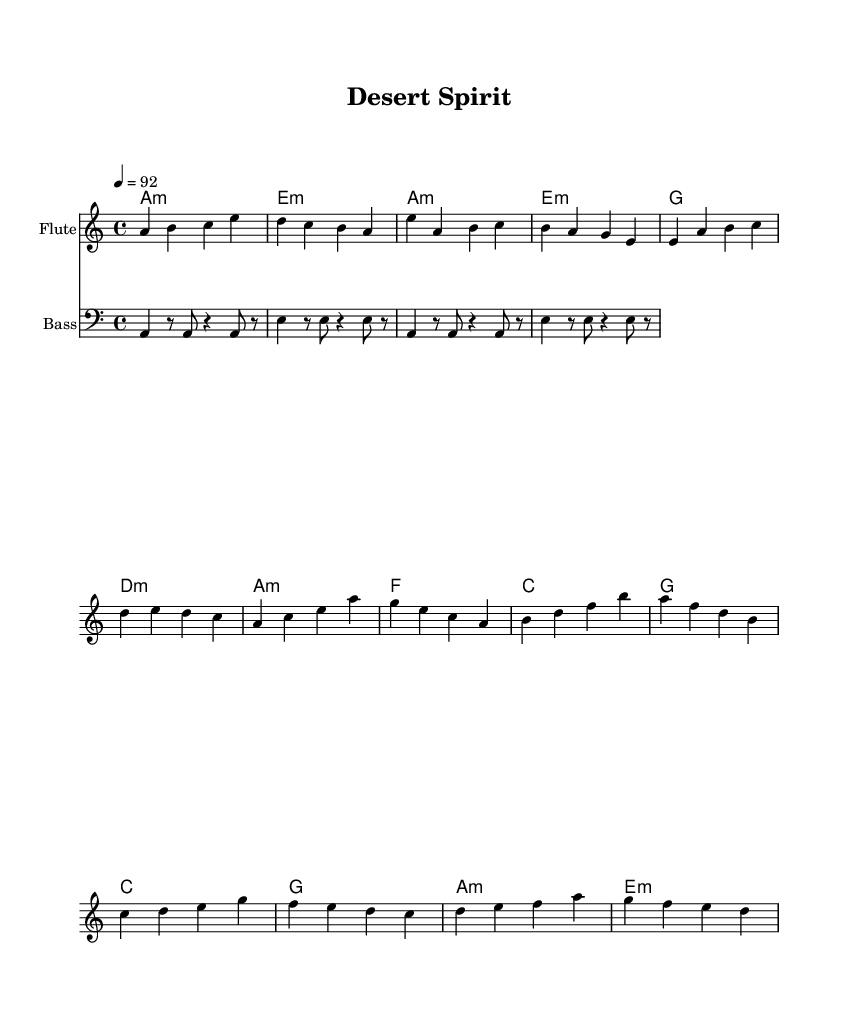What is the key signature of this music? The key signature is indicated as A minor, which has no sharps or flats. A minor is the relative minor of C major, so it follows the same key signature.
Answer: A minor What is the time signature of this music? The time signature is indicated at the beginning of the score. It shows four beats in a measure, represented by 4/4. This means there are four quarter note beats per measure.
Answer: 4/4 What is the tempo marking of this music? The tempo is indicated as 92 beats per minute. This is specified by the '4 = 92' marking, which indicates the speed at which the piece should be played.
Answer: 92 How many measures are in the flute section? Counting the measures for the flute, there are a total of 12 measures in the fluteIntro, fluteVerse, fluteChorus, and fluteBridge sections. Each section can be measured visually by counting the individual segments.
Answer: 12 What is the first chord played in the guitar part? The first chord in the guitar part is indicated as A minor, which is the first entry in the chord progression. This is a common way to open a piece, setting the tonal framework.
Answer: A minor Which instrument has the lowest pitch range in this score? The bass instrument plays the lowest pitches and is notated in the bass clef. By visualizing the staff, we can see that the notes played here are consistently lower than those in the flute part.
Answer: Bass What type of influence is reflected in this music? The music incorporates Native American influences, as noted in the context provided. The blending of contemporary R&B with these elements is a distinctive feature of the piece.
Answer: Native American 